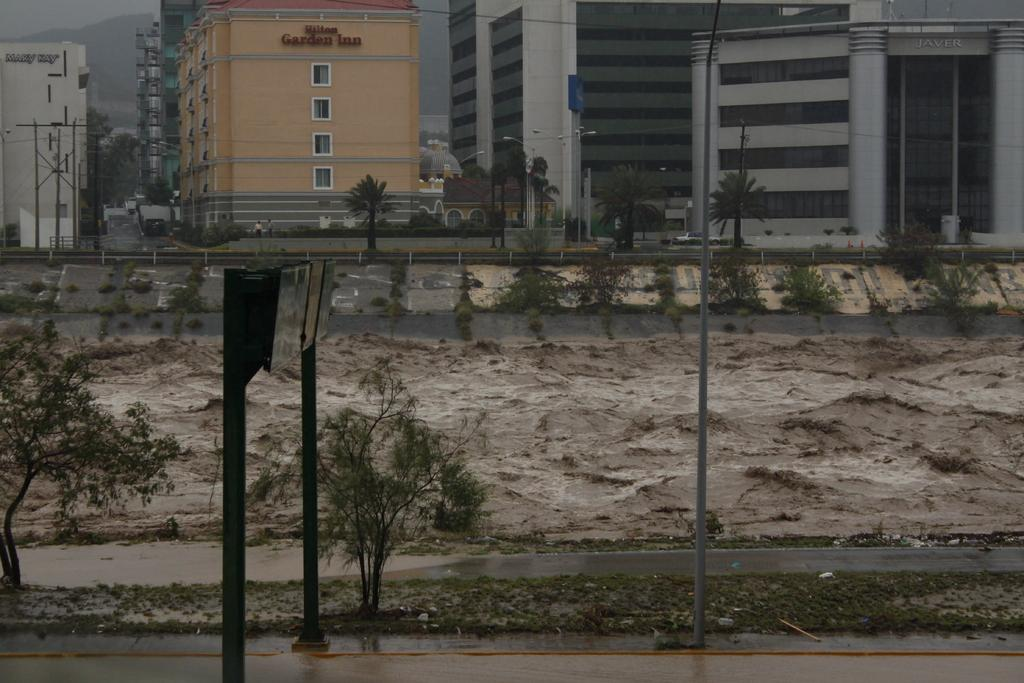What is the main feature of the image? The main feature of the image is a water surface. What can be inferred about the area around the water surface? The area around the water surface is wet. What can be seen in the background of the image? There are many buildings and some trees in the background of the image. What type of lumber is being used to construct the hall in the image? There is no hall or lumber present in the image; it only features a water surface and its surroundings. What time is displayed on the watch in the image? There is no watch present in the image. 